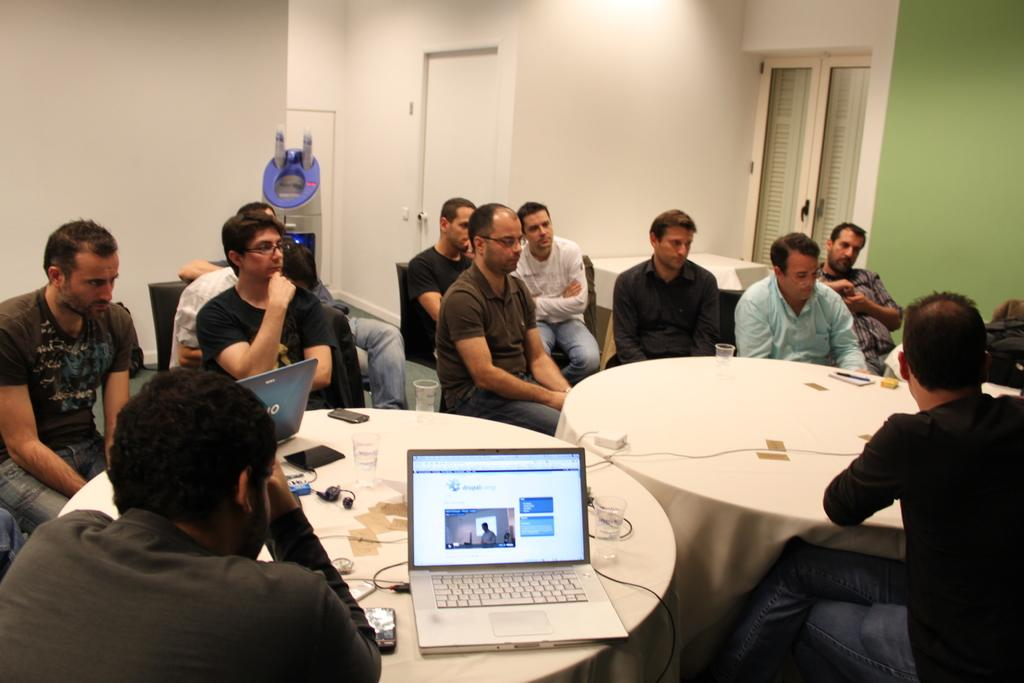What are the people in the image doing? The people in the image are sitting. What electronic devices can be seen in the image? There are laptops in the image. What might be used to connect the laptops to power or other devices? Cables are visible in the image. What objects might be used for vision correction? Glasses are present in the image. What type of furniture is visible in the image? There are objects on tables in the image. What architectural features can be seen in the background of the image? There is a wall, a door, and a window in the background of the image. What other object can be seen in the background of the image? There is an object in the background of the image. How many kittens are attempting to cause a commotion in the image? There are no kittens present in the image, and therefore no such activity can be observed. 